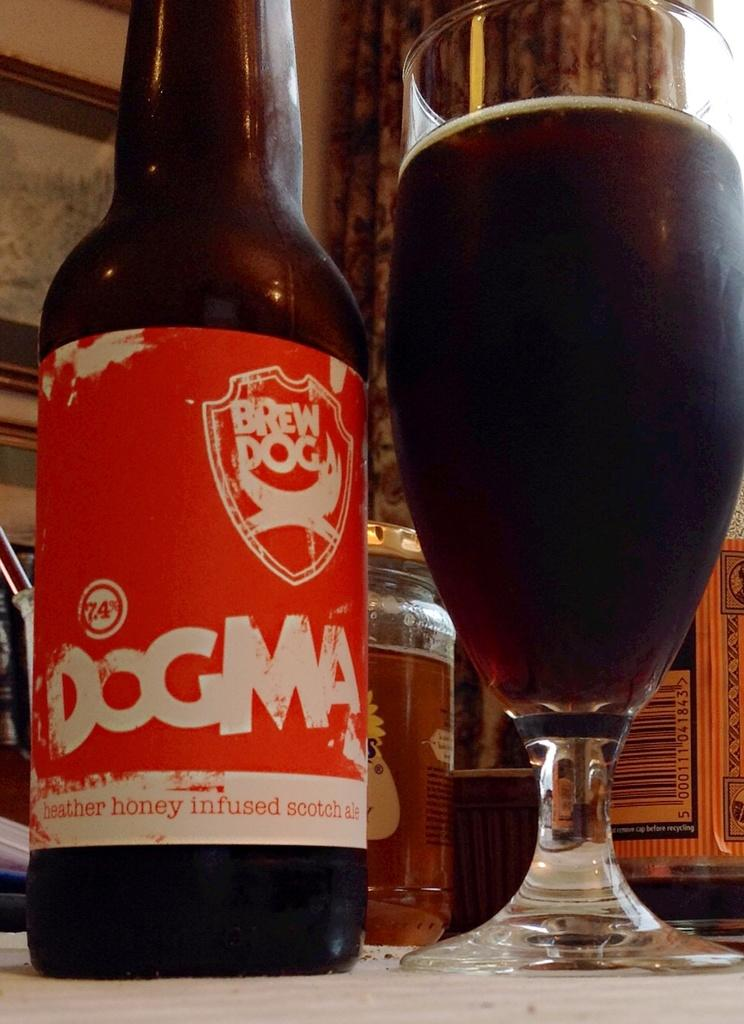<image>
Share a concise interpretation of the image provided. A bottle with a glass beside it and the bottle says DOGMA Brew 